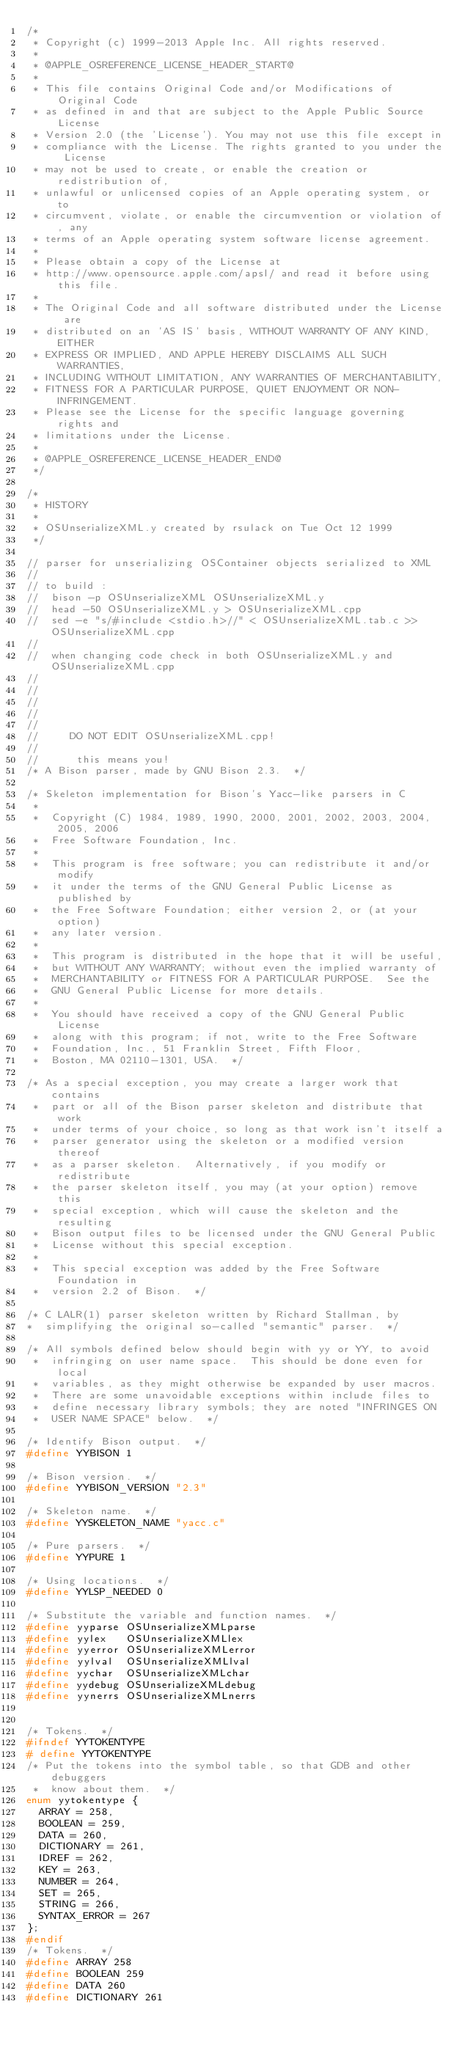<code> <loc_0><loc_0><loc_500><loc_500><_C++_>/*
 * Copyright (c) 1999-2013 Apple Inc. All rights reserved.
 *
 * @APPLE_OSREFERENCE_LICENSE_HEADER_START@
 *
 * This file contains Original Code and/or Modifications of Original Code
 * as defined in and that are subject to the Apple Public Source License
 * Version 2.0 (the 'License'). You may not use this file except in
 * compliance with the License. The rights granted to you under the License
 * may not be used to create, or enable the creation or redistribution of,
 * unlawful or unlicensed copies of an Apple operating system, or to
 * circumvent, violate, or enable the circumvention or violation of, any
 * terms of an Apple operating system software license agreement.
 *
 * Please obtain a copy of the License at
 * http://www.opensource.apple.com/apsl/ and read it before using this file.
 *
 * The Original Code and all software distributed under the License are
 * distributed on an 'AS IS' basis, WITHOUT WARRANTY OF ANY KIND, EITHER
 * EXPRESS OR IMPLIED, AND APPLE HEREBY DISCLAIMS ALL SUCH WARRANTIES,
 * INCLUDING WITHOUT LIMITATION, ANY WARRANTIES OF MERCHANTABILITY,
 * FITNESS FOR A PARTICULAR PURPOSE, QUIET ENJOYMENT OR NON-INFRINGEMENT.
 * Please see the License for the specific language governing rights and
 * limitations under the License.
 *
 * @APPLE_OSREFERENCE_LICENSE_HEADER_END@
 */

/*
 * HISTORY
 *
 * OSUnserializeXML.y created by rsulack on Tue Oct 12 1999
 */

// parser for unserializing OSContainer objects serialized to XML
//
// to build :
//	bison -p OSUnserializeXML OSUnserializeXML.y
//	head -50 OSUnserializeXML.y > OSUnserializeXML.cpp
//	sed -e "s/#include <stdio.h>//" < OSUnserializeXML.tab.c >> OSUnserializeXML.cpp
//
//	when changing code check in both OSUnserializeXML.y and OSUnserializeXML.cpp
//
//
//
//
//
//		 DO NOT EDIT OSUnserializeXML.cpp!
//
//			this means you!
/* A Bison parser, made by GNU Bison 2.3.  */

/* Skeleton implementation for Bison's Yacc-like parsers in C
 *
 *  Copyright (C) 1984, 1989, 1990, 2000, 2001, 2002, 2003, 2004, 2005, 2006
 *  Free Software Foundation, Inc.
 *
 *  This program is free software; you can redistribute it and/or modify
 *  it under the terms of the GNU General Public License as published by
 *  the Free Software Foundation; either version 2, or (at your option)
 *  any later version.
 *
 *  This program is distributed in the hope that it will be useful,
 *  but WITHOUT ANY WARRANTY; without even the implied warranty of
 *  MERCHANTABILITY or FITNESS FOR A PARTICULAR PURPOSE.  See the
 *  GNU General Public License for more details.
 *
 *  You should have received a copy of the GNU General Public License
 *  along with this program; if not, write to the Free Software
 *  Foundation, Inc., 51 Franklin Street, Fifth Floor,
 *  Boston, MA 02110-1301, USA.  */

/* As a special exception, you may create a larger work that contains
 *  part or all of the Bison parser skeleton and distribute that work
 *  under terms of your choice, so long as that work isn't itself a
 *  parser generator using the skeleton or a modified version thereof
 *  as a parser skeleton.  Alternatively, if you modify or redistribute
 *  the parser skeleton itself, you may (at your option) remove this
 *  special exception, which will cause the skeleton and the resulting
 *  Bison output files to be licensed under the GNU General Public
 *  License without this special exception.
 *
 *  This special exception was added by the Free Software Foundation in
 *  version 2.2 of Bison.  */

/* C LALR(1) parser skeleton written by Richard Stallman, by
*  simplifying the original so-called "semantic" parser.  */

/* All symbols defined below should begin with yy or YY, to avoid
 *  infringing on user name space.  This should be done even for local
 *  variables, as they might otherwise be expanded by user macros.
 *  There are some unavoidable exceptions within include files to
 *  define necessary library symbols; they are noted "INFRINGES ON
 *  USER NAME SPACE" below.  */

/* Identify Bison output.  */
#define YYBISON 1

/* Bison version.  */
#define YYBISON_VERSION "2.3"

/* Skeleton name.  */
#define YYSKELETON_NAME "yacc.c"

/* Pure parsers.  */
#define YYPURE 1

/* Using locations.  */
#define YYLSP_NEEDED 0

/* Substitute the variable and function names.  */
#define yyparse OSUnserializeXMLparse
#define yylex   OSUnserializeXMLlex
#define yyerror OSUnserializeXMLerror
#define yylval  OSUnserializeXMLlval
#define yychar  OSUnserializeXMLchar
#define yydebug OSUnserializeXMLdebug
#define yynerrs OSUnserializeXMLnerrs


/* Tokens.  */
#ifndef YYTOKENTYPE
# define YYTOKENTYPE
/* Put the tokens into the symbol table, so that GDB and other debuggers
 *  know about them.  */
enum yytokentype {
	ARRAY = 258,
	BOOLEAN = 259,
	DATA = 260,
	DICTIONARY = 261,
	IDREF = 262,
	KEY = 263,
	NUMBER = 264,
	SET = 265,
	STRING = 266,
	SYNTAX_ERROR = 267
};
#endif
/* Tokens.  */
#define ARRAY 258
#define BOOLEAN 259
#define DATA 260
#define DICTIONARY 261</code> 